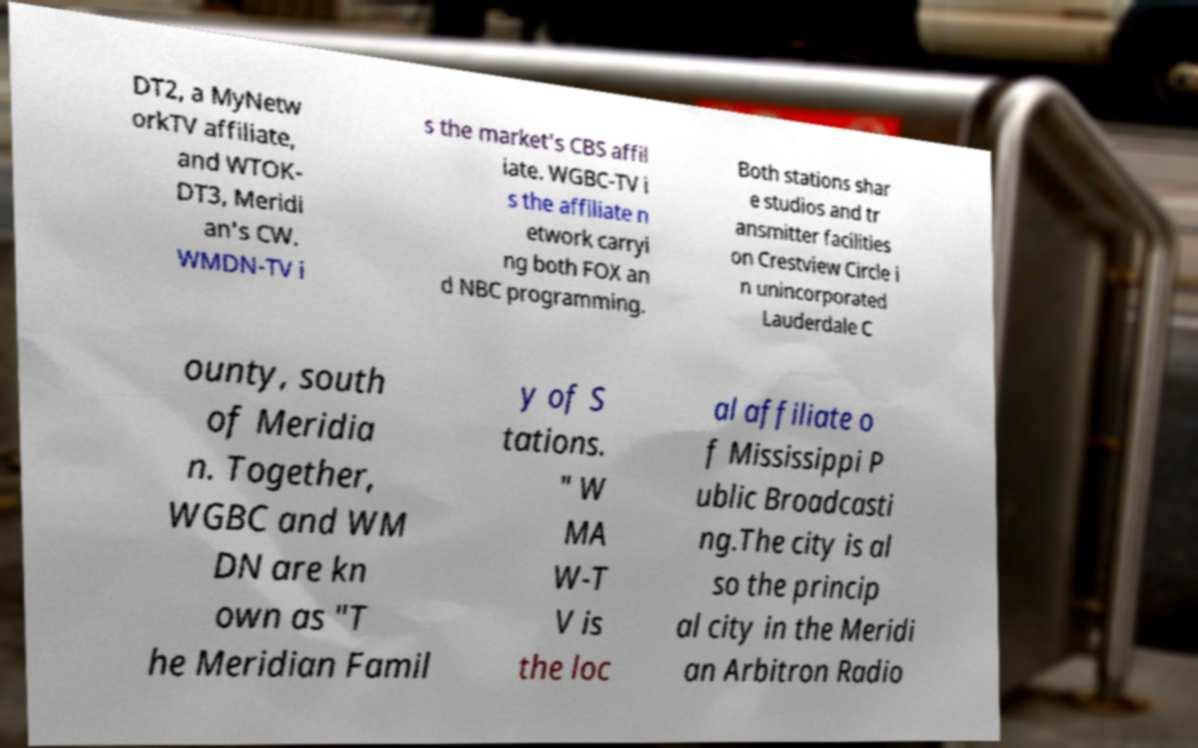What messages or text are displayed in this image? I need them in a readable, typed format. DT2, a MyNetw orkTV affiliate, and WTOK- DT3, Meridi an's CW. WMDN-TV i s the market's CBS affil iate. WGBC-TV i s the affiliate n etwork carryi ng both FOX an d NBC programming. Both stations shar e studios and tr ansmitter facilities on Crestview Circle i n unincorporated Lauderdale C ounty, south of Meridia n. Together, WGBC and WM DN are kn own as "T he Meridian Famil y of S tations. " W MA W-T V is the loc al affiliate o f Mississippi P ublic Broadcasti ng.The city is al so the princip al city in the Meridi an Arbitron Radio 